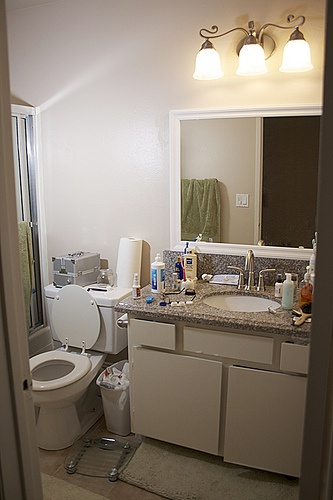Describe the objects in this image and their specific colors. I can see toilet in gray, darkgray, and black tones, sink in gray, darkgray, and tan tones, toothbrush in gray, brown, lightpink, and purple tones, and toothbrush in gray, navy, lightgray, and darkblue tones in this image. 